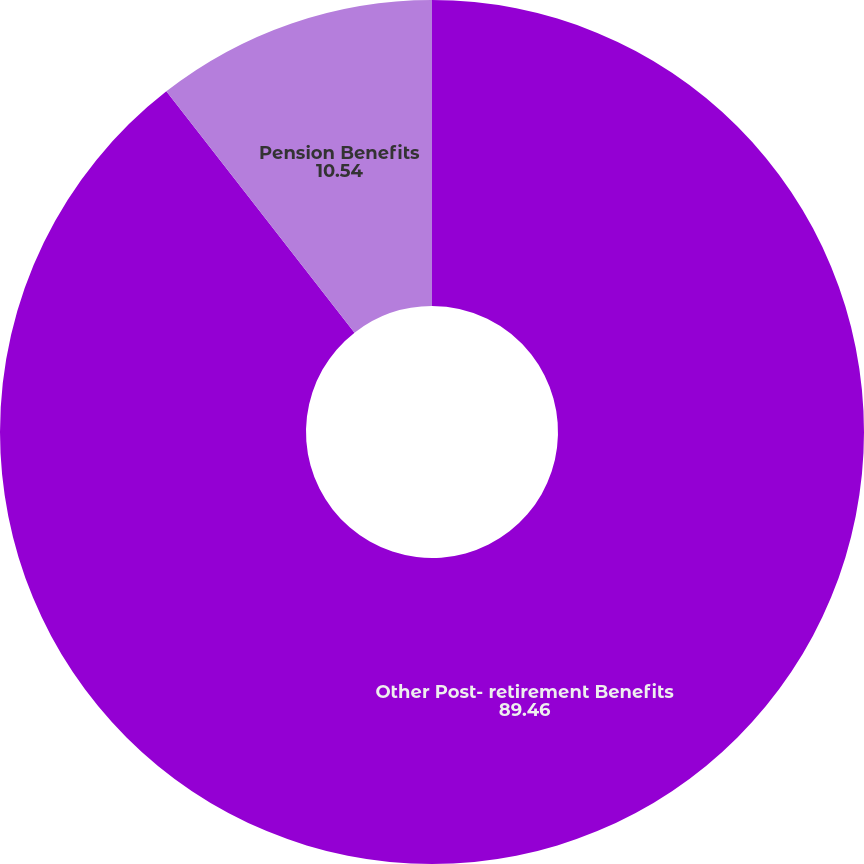Convert chart. <chart><loc_0><loc_0><loc_500><loc_500><pie_chart><fcel>Other Post- retirement Benefits<fcel>Pension Benefits<nl><fcel>89.46%<fcel>10.54%<nl></chart> 